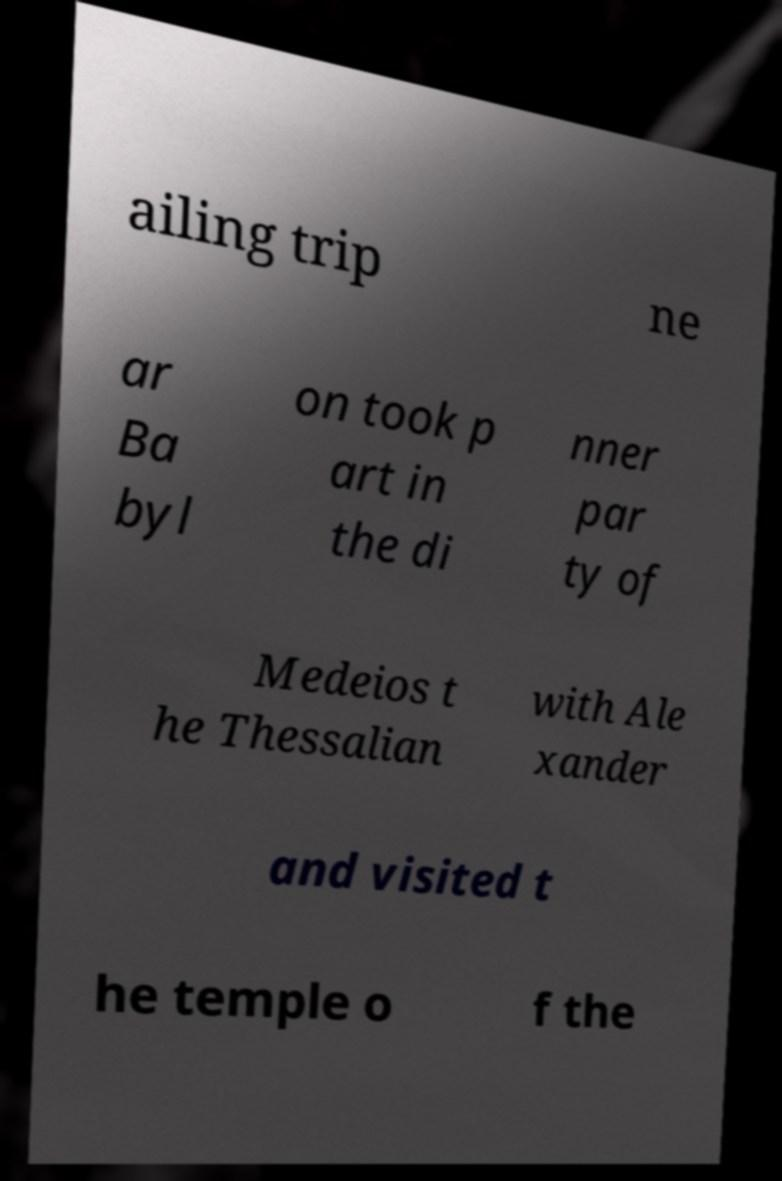For documentation purposes, I need the text within this image transcribed. Could you provide that? ailing trip ne ar Ba byl on took p art in the di nner par ty of Medeios t he Thessalian with Ale xander and visited t he temple o f the 